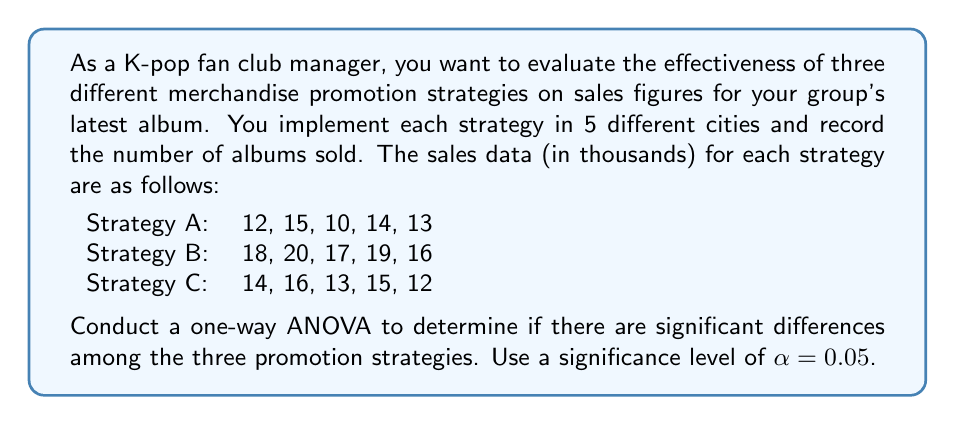Help me with this question. To conduct a one-way ANOVA, we'll follow these steps:

1. Calculate the sum of squares between groups (SSB), within groups (SSW), and total (SST).
2. Calculate the degrees of freedom for between groups (dfB), within groups (dfW), and total (dfT).
3. Calculate the mean squares for between groups (MSB) and within groups (MSW).
4. Calculate the F-statistic.
5. Compare the F-statistic to the critical F-value.

Step 1: Calculate sum of squares

First, we need to calculate the grand mean:
$\bar{X} = \frac{12+15+10+14+13+18+20+17+19+16+14+16+13+15+12}{15} = 14.93$

Now, we can calculate SSB, SSW, and SST:

SSB = $\sum_{i=1}^{k} n_i(\bar{X}_i - \bar{X})^2$
    = $5(12.8 - 14.93)^2 + 5(18 - 14.93)^2 + 5(14 - 14.93)^2$
    = $5(-2.13)^2 + 5(3.07)^2 + 5(-0.93)^2$
    = $22.6845 + 47.1245 + 4.3245 = 74.1335$

SSW = $\sum_{i=1}^{k} \sum_{j=1}^{n_i} (X_{ij} - \bar{X}_i)^2$
    = $[(12-12.8)^2 + (15-12.8)^2 + (10-12.8)^2 + (14-12.8)^2 + (13-12.8)^2]$
    + $[(18-18)^2 + (20-18)^2 + (17-18)^2 + (19-18)^2 + (16-18)^2]$
    + $[(14-14)^2 + (16-14)^2 + (13-14)^2 + (15-14)^2 + (12-14)^2]$
    = $16.8 + 14 + 14 = 44.8$

SST = SSB + SSW = $74.1335 + 44.8 = 118.9335$

Step 2: Calculate degrees of freedom

dfB = $k - 1 = 3 - 1 = 2$
dfW = $N - k = 15 - 3 = 12$
dfT = $N - 1 = 15 - 1 = 14$

Step 3: Calculate mean squares

MSB = $\frac{SSB}{dfB} = \frac{74.1335}{2} = 37.06675$
MSW = $\frac{SSW}{dfW} = \frac{44.8}{12} = 3.73333$

Step 4: Calculate F-statistic

$F = \frac{MSB}{MSW} = \frac{37.06675}{3.73333} = 9.93$

Step 5: Compare F-statistic to critical F-value

The critical F-value for $\alpha = 0.05$, dfB = 2, and dfW = 12 is approximately 3.89.

Since our calculated F-statistic (9.93) is greater than the critical F-value (3.89), we reject the null hypothesis.
Answer: Reject the null hypothesis. There are significant differences among the three promotion strategies (F(2,12) = 9.93, p < 0.05). 